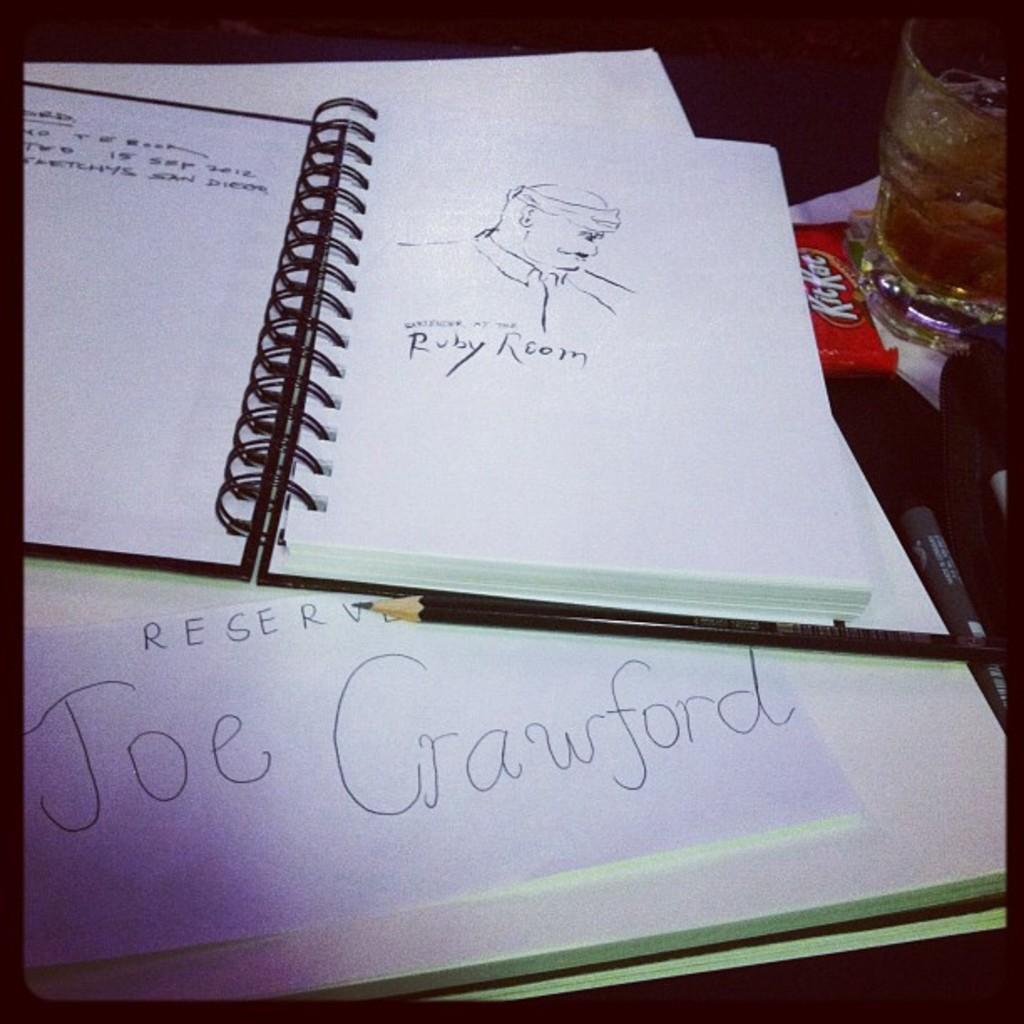What is the name of the person reserved as been made for?
Ensure brevity in your answer.  Joe crawford. What kind of candy bar?
Your answer should be very brief. Kitkat. 